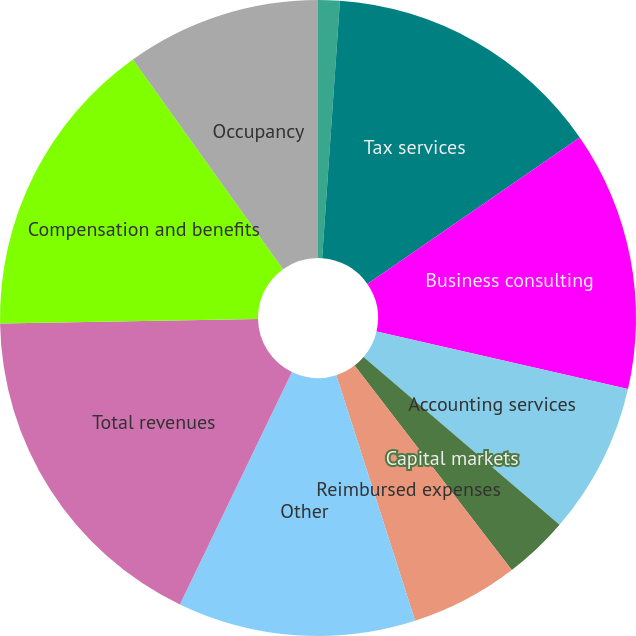<chart> <loc_0><loc_0><loc_500><loc_500><pie_chart><fcel>Year Ended April 30<fcel>Tax services<fcel>Business consulting<fcel>Accounting services<fcel>Capital markets<fcel>Reimbursed expenses<fcel>Other<fcel>Total revenues<fcel>Compensation and benefits<fcel>Occupancy<nl><fcel>1.1%<fcel>14.29%<fcel>13.19%<fcel>7.69%<fcel>3.3%<fcel>5.49%<fcel>12.09%<fcel>17.58%<fcel>15.38%<fcel>9.89%<nl></chart> 